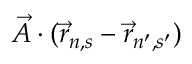<formula> <loc_0><loc_0><loc_500><loc_500>{ \vec { A } } \cdot ( { \vec { r } } _ { n , s } - { \vec { r } } _ { n ^ { \prime } , s ^ { \prime } } )</formula> 